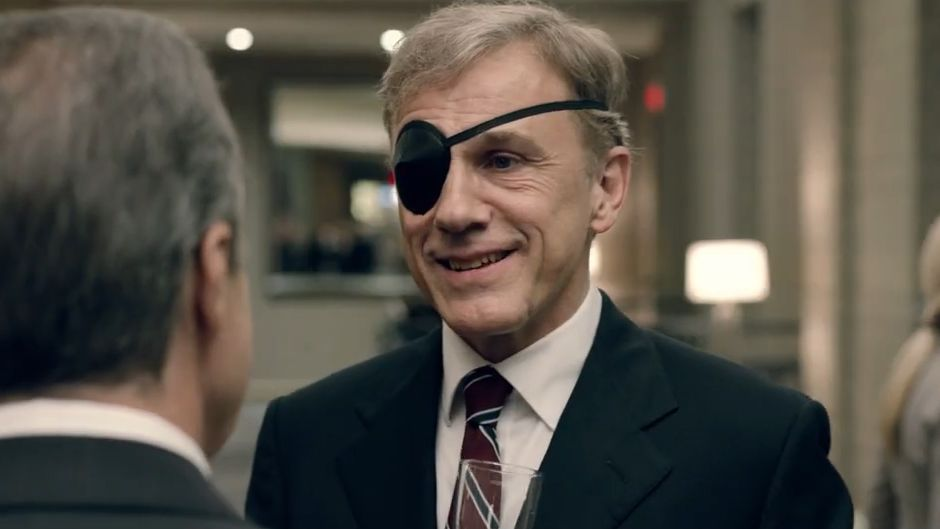Imagine an elaborate backstory for the character portrayed by Christoph Waltz in this scene. In this scene, Christoph Waltz portrays Dr. Johann Richter, a distinguished yet enigmatic neuroscientist known for his groundbreaking research in cognitive enhancement. Dr. Richter's polished appearance and sophisticated demeanor are characteristic of someone who has spent years navigating the complex world of academia and business. The eye patch, stemming from a mysterious accident during a high-stakes experiment, adds an air of intrigue to his persona, leaving many to speculate about the true nature of his research. This evening, he is attending the annual gala of The Foundation for Cognitive Excellence, where he is to be honored for his latest contribution to the field. Amidst the casual conversations, there are whispers of the transformative potential of his work and the ethical dilemmas it may pose. 